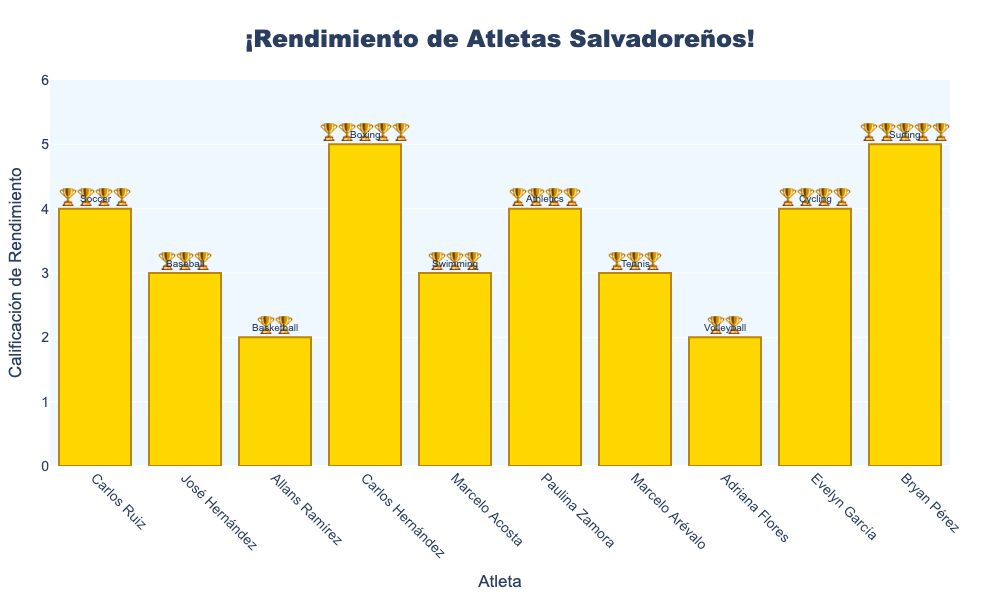What's the title of the chart? The title is usually located at the top of the chart and indicates the subject or main idea. In this case, the title is prominently displayed and reads "¡Rendimiento de Atletas Salvadoreños!"
Answer: ¡Rendimiento de Atletas Salvadoreños! Which athlete has the highest performance rating? The athlete with the highest bar represents the highest performance rating. In this chart, the highest rating of 🏆🏆🏆🏆🏆 belongs to two athletes: Carlos Hernández and Bryan Pérez.
Answer: Carlos Hernández and Bryan Pérez What is the performance rating for Marcelo Acosta? Check the bar labeled 'Marcelo Acosta' and note the emojis displayed. Marcelo Acosta's performance rating is 🏆🏆🏆.
Answer: 🏆🏆🏆 Which sport does Evelyn García participate in, and what is her performance rating? Find the bar labeled 'Evelyn García,' observe the annotation above the bar for the sport (Cycling), and note the performance rating (🏆🏆🏆🏆).
Answer: Cycling, 🏆🏆🏆🏆 How many athletes have a performance rating of exactly three trophies? Count the bars with exactly three 🏆 emojis. These are José Hernández(🏆🏆🏆), Marcelo Acosta(🏆🏆🏆), Marcelo Arévalo(🏆🏆🏆).
Answer: 3 Which athletes have a lower performance rating than Paulina Zamora? Paulina Zamora has a rating of 🏆🏆🏆🏆. Find athletes with fewer than four 🏆 emojis: José Hernández(🏆🏆🏆), Allans Ramírez(🏆🏆), Marcelo Acosta(🏆🏆🏆), Marcelo Arévalo(🏆🏆🏆), Adriana Flores(🏆🏆).
Answer: José Hernández, Allans Ramírez, Marcelo Acosta, Marcelo Arévalo, Adriana Flores Who has a higher performance rating, Allans Ramírez or Adriana Flores? Compare the bars for Allans Ramírez (🏆🏆) and Adriana Flores (🏆🏆). Both have the same rating of 🏆🏆.
Answer: Both have the same rating What is the average performance rating for all athletes? Add the numeric ratings of all athletes and divide by the number of athletes. The sum of ratings (4+3+2+5+3+4+3+2+4+5) equals 35. There are 10 athletes, so the average rating is 35/10 = 3.5.
Answer: 3.5 Who participates in Tennis, and what is their performance rating? Find the annotation for 'Tennis' above the bar for Marcelo Arévalo. His performance rating is 🏆🏆🏆.
Answer: Marcelo Arévalo, 🏆🏆🏆 